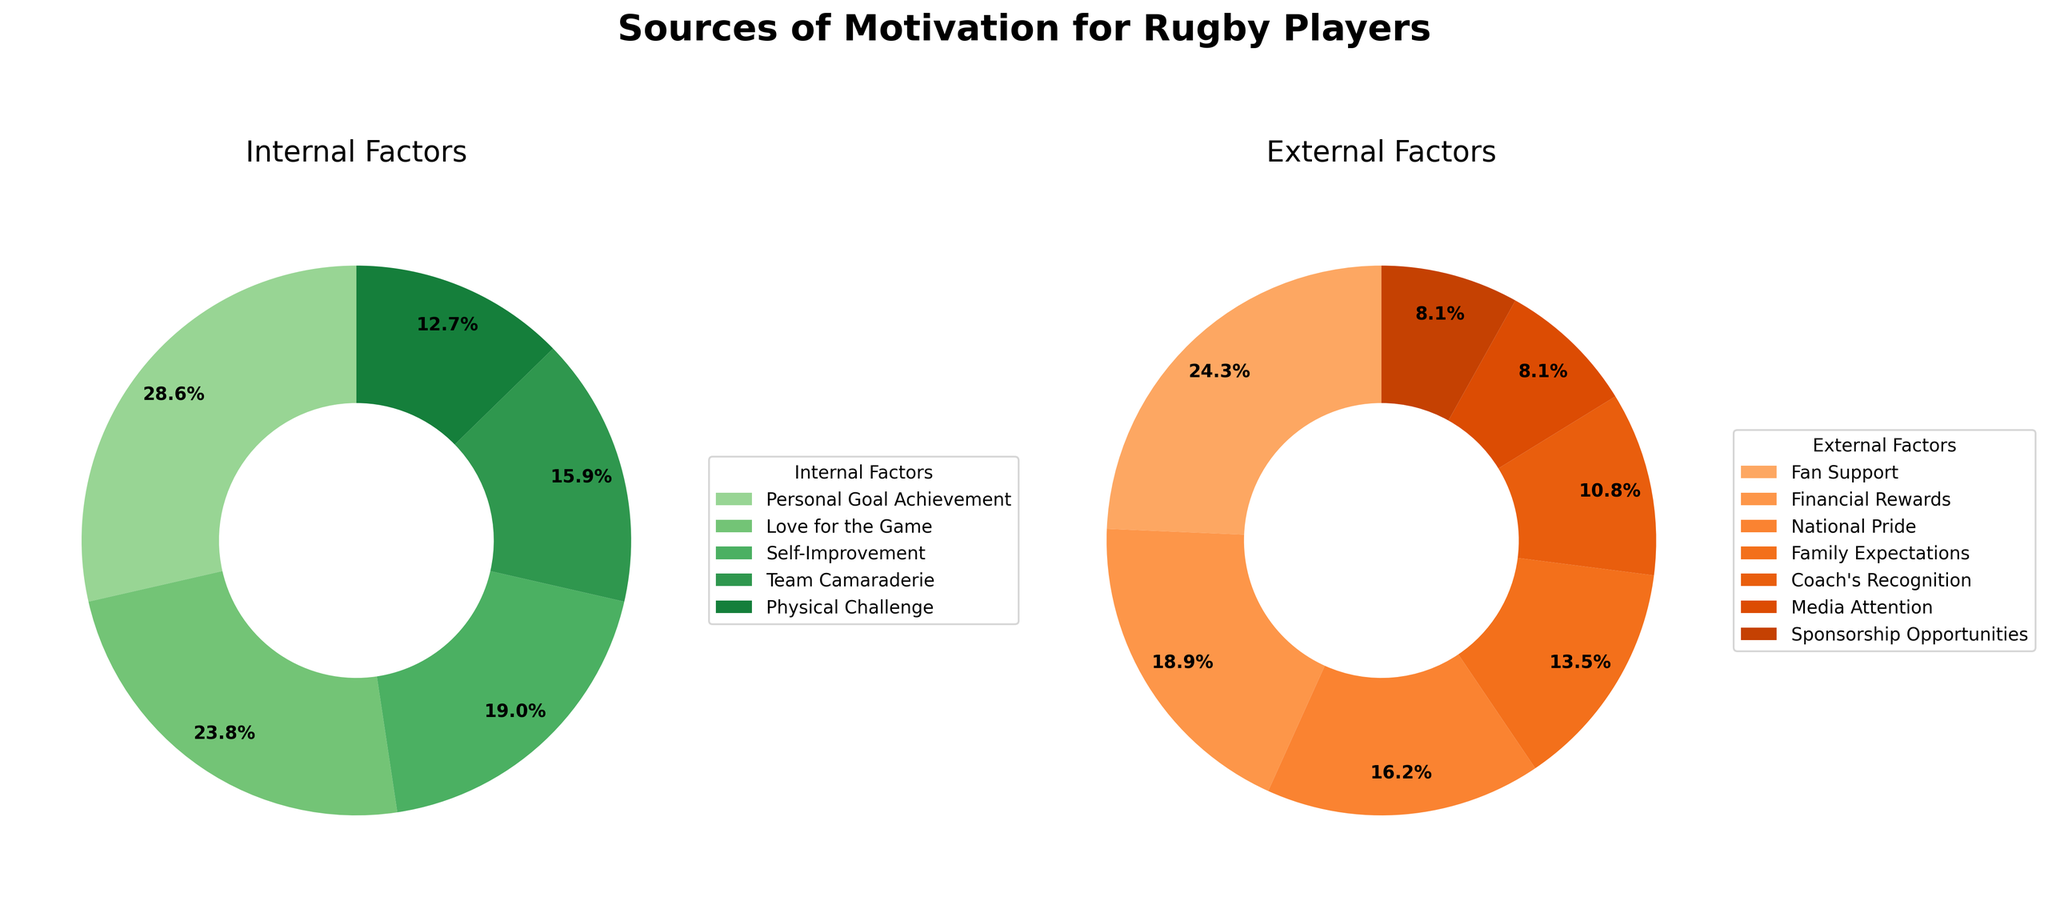What is the percentage of players motivated by personal goal achievement? The percentage of players motivated by personal goal achievement is stated directly in the pie chart under the internal factors section.
Answer: 18% Which factor has a higher percentage of motivation: Fan Support or National Pride? Fan Support is 9%, while National Pride is 6%, as clearly indicated in the external factors pie chart. Comparing the two numbers, we see that Fan Support has a higher percentage.
Answer: Fan Support What is the combined percentage of players motivated by Self-Improvement and Physical Challenge? According to the internal factors pie chart, Self-Improvement stands at 12%, and Physical Challenge is at 8%. Adding these values together gives 12% + 8% = 20%.
Answer: 20% Which section has more total percentage: internal factors or external factors? Summing up all the percentages under internal factors (18% + 15% + 12% + 10% + 8% = 63%) and external factors (9% + 7% + 6% + 5% + 4% + 3% + 3% = 37%), we see that internal factors have a higher total percentage.
Answer: Internal factors Among the external factors, which motivation has the lowest percentage and what is it? In the external factors pie chart, the lowest percentages are 3%, and both Media Attention and Sponsorship Opportunities have this value.
Answer: Media Attention, Sponsorship Opportunities Is the sum of Family Expectations and Coach's Recognition equal to or greater than 10%? Family Expectations is 5%, and Coach's Recognition is 4%. Adding these, we get 5% + 4% = 9%, which is less than 10%.
Answer: No What is the average percentage of the internal factors? The percentages for internal factors are 18%, 15%, 12%, 10%, and 8%. The sum of these is 18 + 15 + 12 + 10 + 8 = 63. The number of internal factors is 5. The average is 63 / 5 = 12.6%.
Answer: 12.6% What motivates rugby players more on average: internal factors or external factors? To find the average of internal factors: Sum is 63% for 5 factors, Average = 63 / 5 = 12.6%. For external factors: Sum is 37% for 7 factors, Average = 37 / 7 ≈ 5.29%. Comparing, 12.6% > 5.29%.
Answer: Internal factors Which internal factor has the least percentage and what is it? The internal factors pie chart shows that Physical Challenge has the least percentage among the internal factors at 8%.
Answer: Physical Challenge 